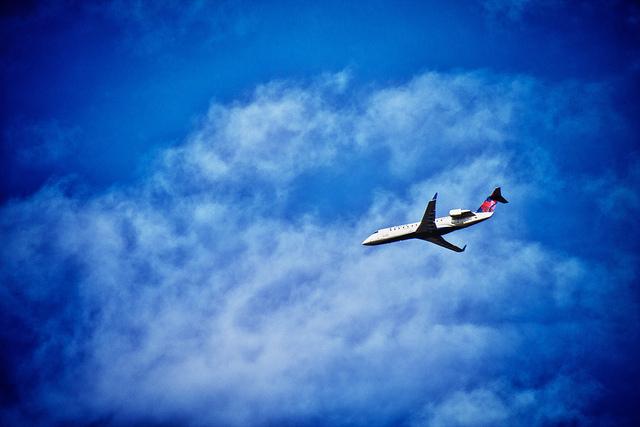IS this a clear sky or stormy?
Give a very brief answer. Clear. How many engines does the plane have?
Answer briefly. 2. Is this plane in the middle of a storm?
Write a very short answer. No. Does the plane appear to be descending?
Quick response, please. Yes. Is the sky clear?
Quick response, please. No. Would this likely be a transatlantic passenger flight?
Concise answer only. Yes. Is the plane a military aircraft?
Short answer required. No. Is the plane about to crash?
Write a very short answer. No. 